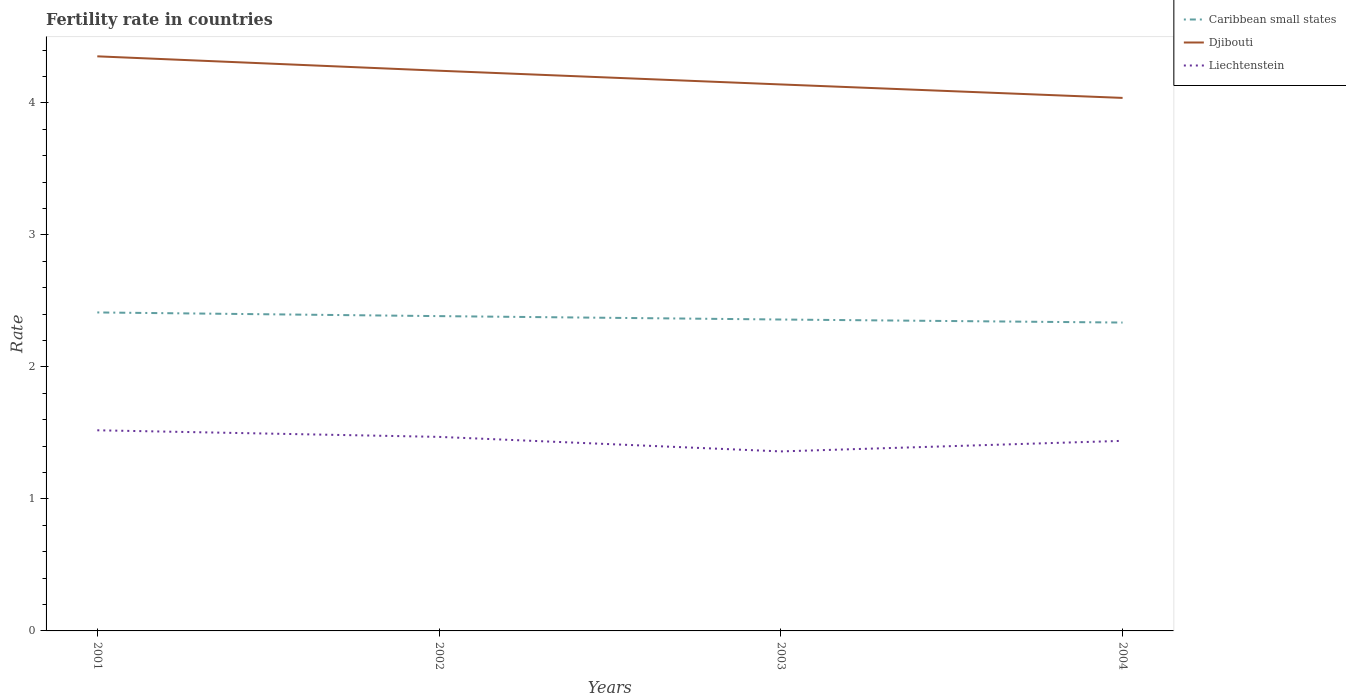Across all years, what is the maximum fertility rate in Djibouti?
Keep it short and to the point. 4.04. In which year was the fertility rate in Djibouti maximum?
Keep it short and to the point. 2004. What is the total fertility rate in Liechtenstein in the graph?
Offer a very short reply. -0.08. What is the difference between the highest and the second highest fertility rate in Djibouti?
Offer a very short reply. 0.31. Is the fertility rate in Liechtenstein strictly greater than the fertility rate in Djibouti over the years?
Keep it short and to the point. Yes. How many lines are there?
Your answer should be very brief. 3. What is the difference between two consecutive major ticks on the Y-axis?
Ensure brevity in your answer.  1. Are the values on the major ticks of Y-axis written in scientific E-notation?
Offer a terse response. No. How many legend labels are there?
Ensure brevity in your answer.  3. How are the legend labels stacked?
Offer a very short reply. Vertical. What is the title of the graph?
Keep it short and to the point. Fertility rate in countries. Does "Nicaragua" appear as one of the legend labels in the graph?
Make the answer very short. No. What is the label or title of the X-axis?
Provide a succinct answer. Years. What is the label or title of the Y-axis?
Offer a very short reply. Rate. What is the Rate in Caribbean small states in 2001?
Your answer should be very brief. 2.41. What is the Rate in Djibouti in 2001?
Ensure brevity in your answer.  4.35. What is the Rate of Liechtenstein in 2001?
Offer a terse response. 1.52. What is the Rate in Caribbean small states in 2002?
Your answer should be very brief. 2.38. What is the Rate in Djibouti in 2002?
Provide a succinct answer. 4.24. What is the Rate in Liechtenstein in 2002?
Provide a succinct answer. 1.47. What is the Rate of Caribbean small states in 2003?
Provide a succinct answer. 2.36. What is the Rate of Djibouti in 2003?
Provide a succinct answer. 4.14. What is the Rate of Liechtenstein in 2003?
Offer a terse response. 1.36. What is the Rate in Caribbean small states in 2004?
Offer a terse response. 2.34. What is the Rate of Djibouti in 2004?
Your response must be concise. 4.04. What is the Rate of Liechtenstein in 2004?
Your answer should be compact. 1.44. Across all years, what is the maximum Rate in Caribbean small states?
Provide a succinct answer. 2.41. Across all years, what is the maximum Rate of Djibouti?
Ensure brevity in your answer.  4.35. Across all years, what is the maximum Rate of Liechtenstein?
Offer a very short reply. 1.52. Across all years, what is the minimum Rate in Caribbean small states?
Offer a terse response. 2.34. Across all years, what is the minimum Rate in Djibouti?
Provide a short and direct response. 4.04. Across all years, what is the minimum Rate of Liechtenstein?
Offer a terse response. 1.36. What is the total Rate in Caribbean small states in the graph?
Your response must be concise. 9.49. What is the total Rate of Djibouti in the graph?
Provide a succinct answer. 16.77. What is the total Rate of Liechtenstein in the graph?
Your answer should be very brief. 5.79. What is the difference between the Rate of Caribbean small states in 2001 and that in 2002?
Your response must be concise. 0.03. What is the difference between the Rate in Djibouti in 2001 and that in 2002?
Offer a very short reply. 0.11. What is the difference between the Rate of Liechtenstein in 2001 and that in 2002?
Offer a terse response. 0.05. What is the difference between the Rate of Caribbean small states in 2001 and that in 2003?
Offer a very short reply. 0.05. What is the difference between the Rate in Djibouti in 2001 and that in 2003?
Make the answer very short. 0.21. What is the difference between the Rate in Liechtenstein in 2001 and that in 2003?
Provide a succinct answer. 0.16. What is the difference between the Rate in Caribbean small states in 2001 and that in 2004?
Offer a terse response. 0.08. What is the difference between the Rate of Djibouti in 2001 and that in 2004?
Keep it short and to the point. 0.32. What is the difference between the Rate in Caribbean small states in 2002 and that in 2003?
Keep it short and to the point. 0.03. What is the difference between the Rate of Djibouti in 2002 and that in 2003?
Offer a very short reply. 0.1. What is the difference between the Rate of Liechtenstein in 2002 and that in 2003?
Keep it short and to the point. 0.11. What is the difference between the Rate in Caribbean small states in 2002 and that in 2004?
Your response must be concise. 0.05. What is the difference between the Rate in Djibouti in 2002 and that in 2004?
Your response must be concise. 0.21. What is the difference between the Rate in Liechtenstein in 2002 and that in 2004?
Offer a terse response. 0.03. What is the difference between the Rate of Caribbean small states in 2003 and that in 2004?
Provide a short and direct response. 0.02. What is the difference between the Rate of Djibouti in 2003 and that in 2004?
Give a very brief answer. 0.1. What is the difference between the Rate of Liechtenstein in 2003 and that in 2004?
Your answer should be very brief. -0.08. What is the difference between the Rate in Caribbean small states in 2001 and the Rate in Djibouti in 2002?
Offer a terse response. -1.83. What is the difference between the Rate in Caribbean small states in 2001 and the Rate in Liechtenstein in 2002?
Your answer should be compact. 0.94. What is the difference between the Rate of Djibouti in 2001 and the Rate of Liechtenstein in 2002?
Keep it short and to the point. 2.88. What is the difference between the Rate of Caribbean small states in 2001 and the Rate of Djibouti in 2003?
Your response must be concise. -1.73. What is the difference between the Rate of Caribbean small states in 2001 and the Rate of Liechtenstein in 2003?
Offer a very short reply. 1.05. What is the difference between the Rate in Djibouti in 2001 and the Rate in Liechtenstein in 2003?
Give a very brief answer. 2.99. What is the difference between the Rate of Caribbean small states in 2001 and the Rate of Djibouti in 2004?
Your answer should be very brief. -1.63. What is the difference between the Rate of Caribbean small states in 2001 and the Rate of Liechtenstein in 2004?
Offer a very short reply. 0.97. What is the difference between the Rate of Djibouti in 2001 and the Rate of Liechtenstein in 2004?
Make the answer very short. 2.91. What is the difference between the Rate in Caribbean small states in 2002 and the Rate in Djibouti in 2003?
Give a very brief answer. -1.76. What is the difference between the Rate in Caribbean small states in 2002 and the Rate in Liechtenstein in 2003?
Provide a short and direct response. 1.02. What is the difference between the Rate in Djibouti in 2002 and the Rate in Liechtenstein in 2003?
Offer a terse response. 2.88. What is the difference between the Rate of Caribbean small states in 2002 and the Rate of Djibouti in 2004?
Your response must be concise. -1.65. What is the difference between the Rate of Caribbean small states in 2002 and the Rate of Liechtenstein in 2004?
Keep it short and to the point. 0.94. What is the difference between the Rate of Djibouti in 2002 and the Rate of Liechtenstein in 2004?
Offer a very short reply. 2.8. What is the difference between the Rate in Caribbean small states in 2003 and the Rate in Djibouti in 2004?
Make the answer very short. -1.68. What is the difference between the Rate of Caribbean small states in 2003 and the Rate of Liechtenstein in 2004?
Your answer should be compact. 0.92. What is the average Rate in Caribbean small states per year?
Offer a terse response. 2.37. What is the average Rate in Djibouti per year?
Offer a very short reply. 4.19. What is the average Rate in Liechtenstein per year?
Your answer should be compact. 1.45. In the year 2001, what is the difference between the Rate of Caribbean small states and Rate of Djibouti?
Your response must be concise. -1.94. In the year 2001, what is the difference between the Rate of Caribbean small states and Rate of Liechtenstein?
Make the answer very short. 0.89. In the year 2001, what is the difference between the Rate in Djibouti and Rate in Liechtenstein?
Your answer should be compact. 2.83. In the year 2002, what is the difference between the Rate in Caribbean small states and Rate in Djibouti?
Provide a succinct answer. -1.86. In the year 2002, what is the difference between the Rate of Caribbean small states and Rate of Liechtenstein?
Give a very brief answer. 0.91. In the year 2002, what is the difference between the Rate in Djibouti and Rate in Liechtenstein?
Your answer should be very brief. 2.77. In the year 2003, what is the difference between the Rate in Caribbean small states and Rate in Djibouti?
Keep it short and to the point. -1.78. In the year 2003, what is the difference between the Rate of Djibouti and Rate of Liechtenstein?
Give a very brief answer. 2.78. In the year 2004, what is the difference between the Rate of Caribbean small states and Rate of Djibouti?
Your response must be concise. -1.7. In the year 2004, what is the difference between the Rate in Caribbean small states and Rate in Liechtenstein?
Provide a succinct answer. 0.9. In the year 2004, what is the difference between the Rate of Djibouti and Rate of Liechtenstein?
Provide a succinct answer. 2.6. What is the ratio of the Rate of Caribbean small states in 2001 to that in 2002?
Your response must be concise. 1.01. What is the ratio of the Rate in Djibouti in 2001 to that in 2002?
Provide a succinct answer. 1.03. What is the ratio of the Rate in Liechtenstein in 2001 to that in 2002?
Ensure brevity in your answer.  1.03. What is the ratio of the Rate in Caribbean small states in 2001 to that in 2003?
Provide a succinct answer. 1.02. What is the ratio of the Rate of Djibouti in 2001 to that in 2003?
Offer a terse response. 1.05. What is the ratio of the Rate of Liechtenstein in 2001 to that in 2003?
Provide a short and direct response. 1.12. What is the ratio of the Rate in Caribbean small states in 2001 to that in 2004?
Give a very brief answer. 1.03. What is the ratio of the Rate in Djibouti in 2001 to that in 2004?
Offer a very short reply. 1.08. What is the ratio of the Rate of Liechtenstein in 2001 to that in 2004?
Offer a terse response. 1.06. What is the ratio of the Rate in Caribbean small states in 2002 to that in 2003?
Your answer should be compact. 1.01. What is the ratio of the Rate in Djibouti in 2002 to that in 2003?
Provide a succinct answer. 1.03. What is the ratio of the Rate in Liechtenstein in 2002 to that in 2003?
Your response must be concise. 1.08. What is the ratio of the Rate in Caribbean small states in 2002 to that in 2004?
Ensure brevity in your answer.  1.02. What is the ratio of the Rate in Djibouti in 2002 to that in 2004?
Your response must be concise. 1.05. What is the ratio of the Rate of Liechtenstein in 2002 to that in 2004?
Offer a terse response. 1.02. What is the ratio of the Rate of Caribbean small states in 2003 to that in 2004?
Provide a succinct answer. 1.01. What is the ratio of the Rate in Djibouti in 2003 to that in 2004?
Give a very brief answer. 1.03. What is the ratio of the Rate of Liechtenstein in 2003 to that in 2004?
Provide a short and direct response. 0.94. What is the difference between the highest and the second highest Rate of Caribbean small states?
Provide a short and direct response. 0.03. What is the difference between the highest and the second highest Rate of Djibouti?
Your answer should be compact. 0.11. What is the difference between the highest and the lowest Rate of Caribbean small states?
Offer a terse response. 0.08. What is the difference between the highest and the lowest Rate in Djibouti?
Make the answer very short. 0.32. What is the difference between the highest and the lowest Rate in Liechtenstein?
Provide a short and direct response. 0.16. 